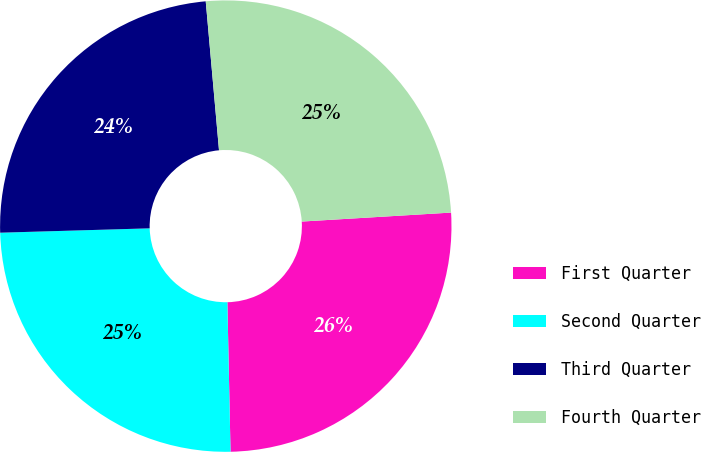Convert chart to OTSL. <chart><loc_0><loc_0><loc_500><loc_500><pie_chart><fcel>First Quarter<fcel>Second Quarter<fcel>Third Quarter<fcel>Fourth Quarter<nl><fcel>25.62%<fcel>24.87%<fcel>24.05%<fcel>25.46%<nl></chart> 